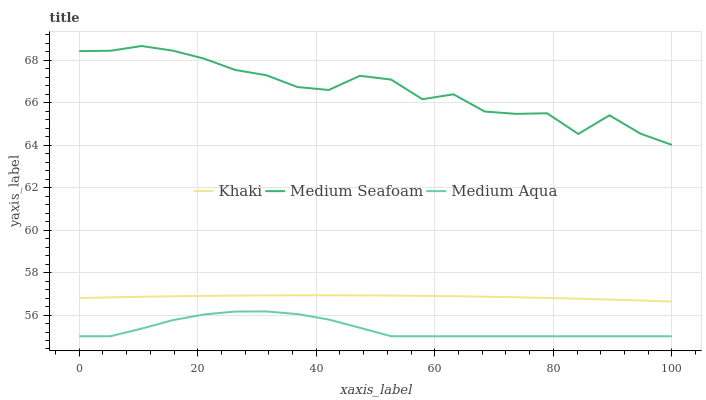Does Medium Aqua have the minimum area under the curve?
Answer yes or no. Yes. Does Medium Seafoam have the maximum area under the curve?
Answer yes or no. Yes. Does Medium Seafoam have the minimum area under the curve?
Answer yes or no. No. Does Medium Aqua have the maximum area under the curve?
Answer yes or no. No. Is Khaki the smoothest?
Answer yes or no. Yes. Is Medium Seafoam the roughest?
Answer yes or no. Yes. Is Medium Aqua the smoothest?
Answer yes or no. No. Is Medium Aqua the roughest?
Answer yes or no. No. Does Medium Aqua have the lowest value?
Answer yes or no. Yes. Does Medium Seafoam have the lowest value?
Answer yes or no. No. Does Medium Seafoam have the highest value?
Answer yes or no. Yes. Does Medium Aqua have the highest value?
Answer yes or no. No. Is Medium Aqua less than Medium Seafoam?
Answer yes or no. Yes. Is Khaki greater than Medium Aqua?
Answer yes or no. Yes. Does Medium Aqua intersect Medium Seafoam?
Answer yes or no. No. 